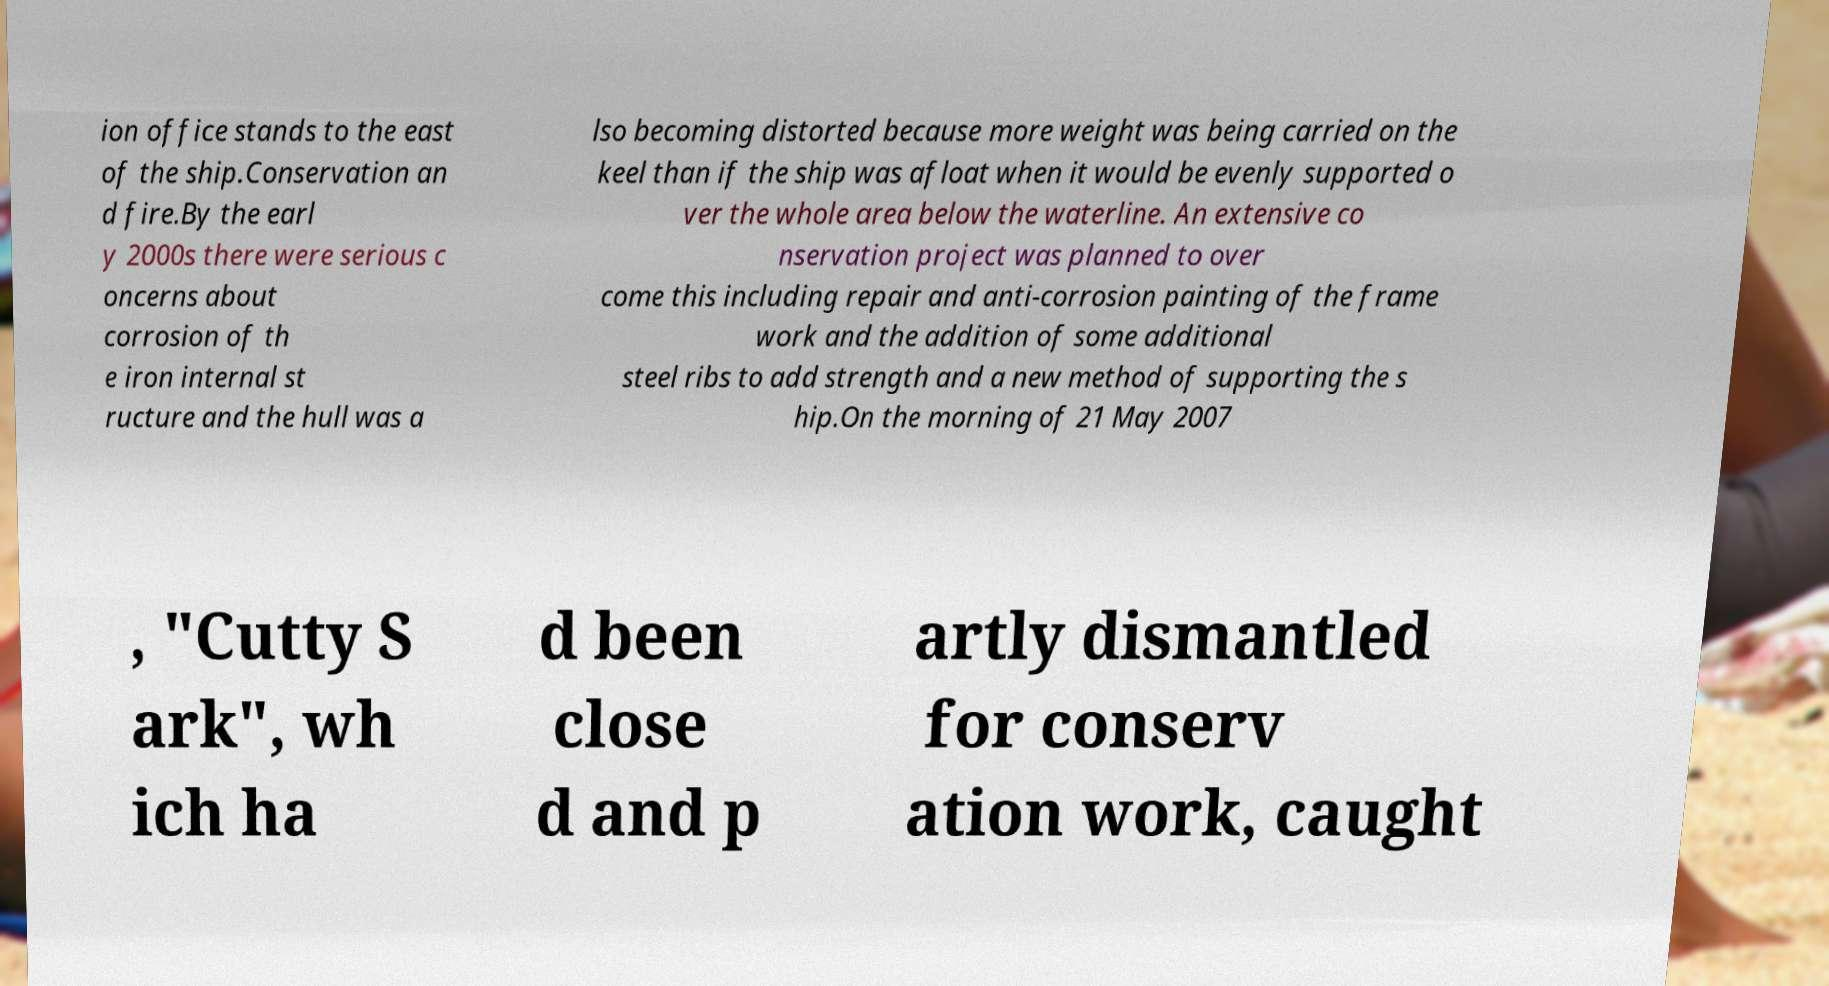Please identify and transcribe the text found in this image. ion office stands to the east of the ship.Conservation an d fire.By the earl y 2000s there were serious c oncerns about corrosion of th e iron internal st ructure and the hull was a lso becoming distorted because more weight was being carried on the keel than if the ship was afloat when it would be evenly supported o ver the whole area below the waterline. An extensive co nservation project was planned to over come this including repair and anti-corrosion painting of the frame work and the addition of some additional steel ribs to add strength and a new method of supporting the s hip.On the morning of 21 May 2007 , "Cutty S ark", wh ich ha d been close d and p artly dismantled for conserv ation work, caught 